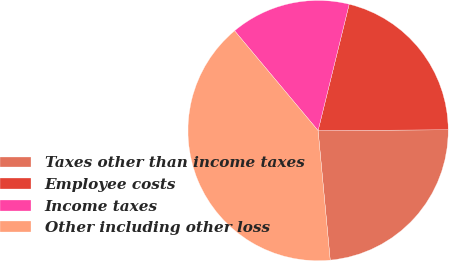Convert chart to OTSL. <chart><loc_0><loc_0><loc_500><loc_500><pie_chart><fcel>Taxes other than income taxes<fcel>Employee costs<fcel>Income taxes<fcel>Other including other loss<nl><fcel>23.61%<fcel>21.06%<fcel>14.93%<fcel>40.39%<nl></chart> 